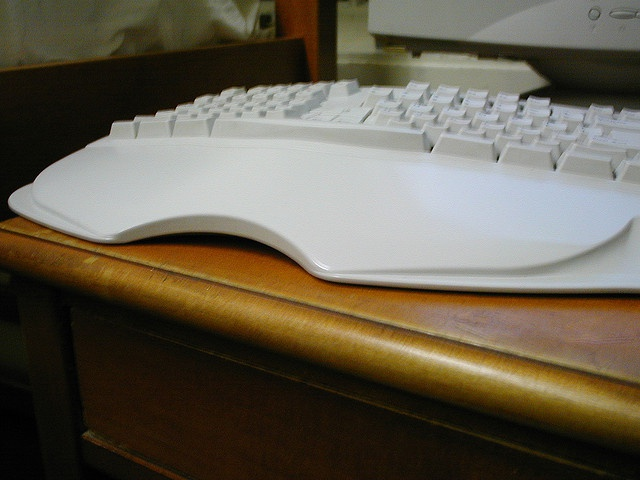Describe the objects in this image and their specific colors. I can see keyboard in darkgreen, darkgray, and lightgray tones and tv in darkgreen, black, and gray tones in this image. 